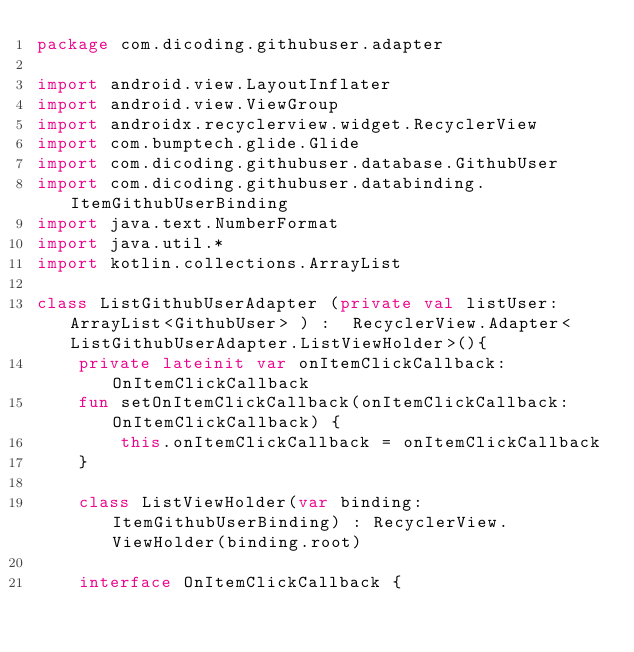<code> <loc_0><loc_0><loc_500><loc_500><_Kotlin_>package com.dicoding.githubuser.adapter

import android.view.LayoutInflater
import android.view.ViewGroup
import androidx.recyclerview.widget.RecyclerView
import com.bumptech.glide.Glide
import com.dicoding.githubuser.database.GithubUser
import com.dicoding.githubuser.databinding.ItemGithubUserBinding
import java.text.NumberFormat
import java.util.*
import kotlin.collections.ArrayList

class ListGithubUserAdapter (private val listUser: ArrayList<GithubUser> ) :  RecyclerView.Adapter<ListGithubUserAdapter.ListViewHolder>(){
    private lateinit var onItemClickCallback: OnItemClickCallback
    fun setOnItemClickCallback(onItemClickCallback: OnItemClickCallback) {
        this.onItemClickCallback = onItemClickCallback
    }

    class ListViewHolder(var binding: ItemGithubUserBinding) : RecyclerView.ViewHolder(binding.root)

    interface OnItemClickCallback {</code> 